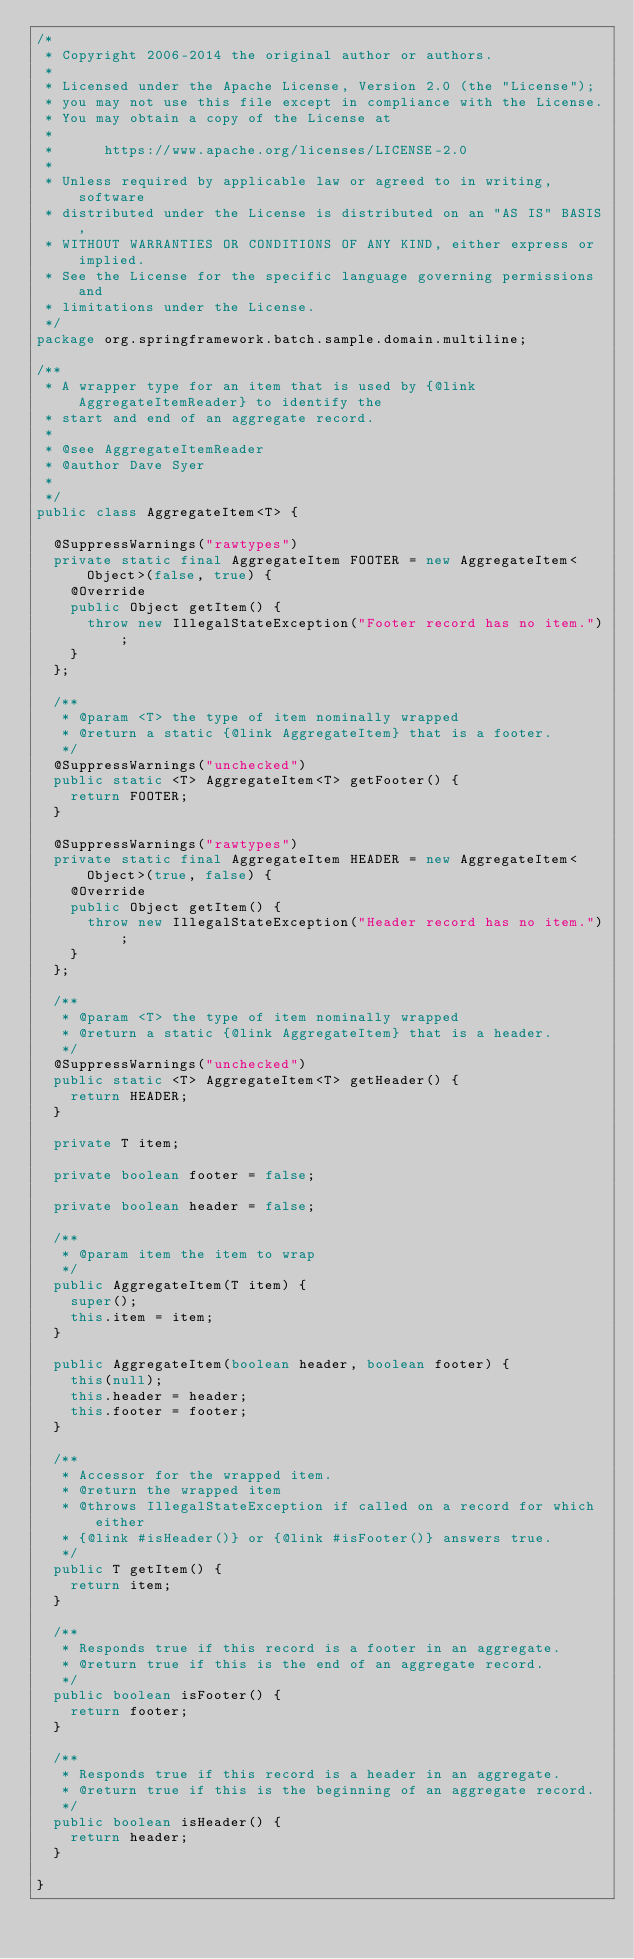Convert code to text. <code><loc_0><loc_0><loc_500><loc_500><_Java_>/*
 * Copyright 2006-2014 the original author or authors.
 *
 * Licensed under the Apache License, Version 2.0 (the "License");
 * you may not use this file except in compliance with the License.
 * You may obtain a copy of the License at
 *
 *      https://www.apache.org/licenses/LICENSE-2.0
 *
 * Unless required by applicable law or agreed to in writing, software
 * distributed under the License is distributed on an "AS IS" BASIS,
 * WITHOUT WARRANTIES OR CONDITIONS OF ANY KIND, either express or implied.
 * See the License for the specific language governing permissions and
 * limitations under the License.
 */
package org.springframework.batch.sample.domain.multiline;

/**
 * A wrapper type for an item that is used by {@link AggregateItemReader} to identify the
 * start and end of an aggregate record.
 *
 * @see AggregateItemReader
 * @author Dave Syer
 *
 */
public class AggregateItem<T> {

	@SuppressWarnings("rawtypes")
	private static final AggregateItem FOOTER = new AggregateItem<Object>(false, true) {
		@Override
		public Object getItem() {
			throw new IllegalStateException("Footer record has no item.");
		}
	};

	/**
	 * @param <T> the type of item nominally wrapped
	 * @return a static {@link AggregateItem} that is a footer.
	 */
	@SuppressWarnings("unchecked")
	public static <T> AggregateItem<T> getFooter() {
		return FOOTER;
	}

	@SuppressWarnings("rawtypes")
	private static final AggregateItem HEADER = new AggregateItem<Object>(true, false) {
		@Override
		public Object getItem() {
			throw new IllegalStateException("Header record has no item.");
		}
	};

	/**
	 * @param <T> the type of item nominally wrapped
	 * @return a static {@link AggregateItem} that is a header.
	 */
	@SuppressWarnings("unchecked")
	public static <T> AggregateItem<T> getHeader() {
		return HEADER;
	}

	private T item;

	private boolean footer = false;

	private boolean header = false;

	/**
	 * @param item the item to wrap
	 */
	public AggregateItem(T item) {
		super();
		this.item = item;
	}

	public AggregateItem(boolean header, boolean footer) {
		this(null);
		this.header = header;
		this.footer = footer;
	}

	/**
	 * Accessor for the wrapped item.
	 * @return the wrapped item
	 * @throws IllegalStateException if called on a record for which either
	 * {@link #isHeader()} or {@link #isFooter()} answers true.
	 */
	public T getItem() {
		return item;
	}

	/**
	 * Responds true if this record is a footer in an aggregate.
	 * @return true if this is the end of an aggregate record.
	 */
	public boolean isFooter() {
		return footer;
	}

	/**
	 * Responds true if this record is a header in an aggregate.
	 * @return true if this is the beginning of an aggregate record.
	 */
	public boolean isHeader() {
		return header;
	}

}
</code> 